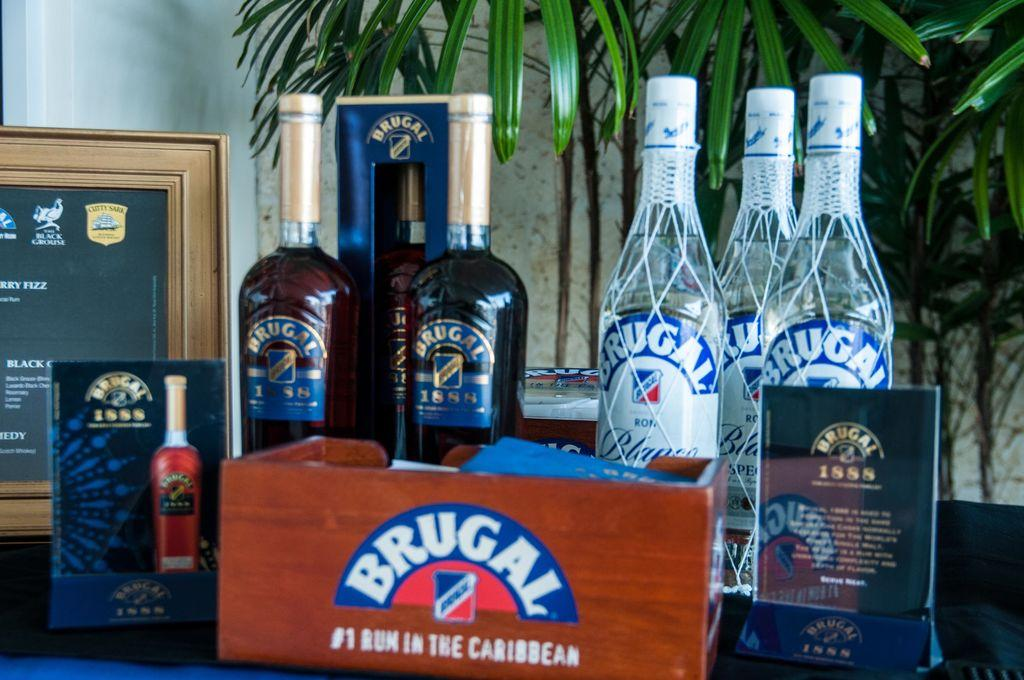What objects are on the table in the image? There are bottles on a table in the image. What can be seen in the background of the image? There is a frame, a wall, and a plant in the background of the image. What type of scarecrow is present in the image? There is no scarecrow present in the image. What mathematical operation is being performed in the image? There is no mathematical operation or addition being performed in the image. 